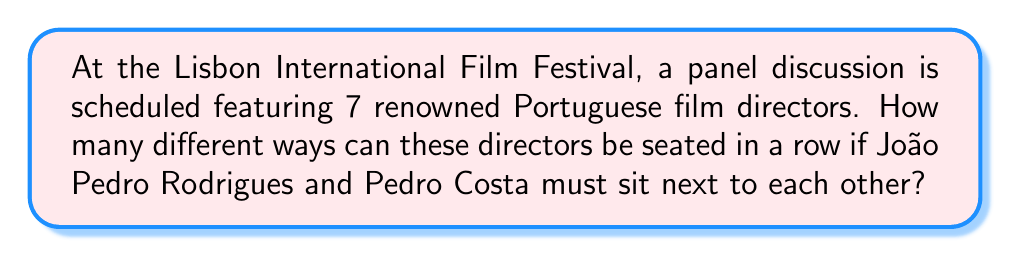Show me your answer to this math problem. Let's approach this step-by-step:

1) First, we need to consider João Pedro Rodrigues and Pedro Costa as a single unit since they must sit next to each other. This reduces our problem to arranging 6 units (the Rodrigues-Costa unit and the other 5 directors).

2) The number of ways to arrange 6 distinct units is a straightforward permutation:

   $P(6) = 6! = 6 \times 5 \times 4 \times 3 \times 2 \times 1 = 720$

3) However, we're not done yet. For each of these 720 arrangements, Rodrigues and Costa can switch their positions with each other. This doubles our possibilities.

4) Therefore, the total number of possible arrangements is:

   $720 \times 2 = 1440$

Thus, there are 1440 different ways to seat the 7 Portuguese film directors with Rodrigues and Costa sitting next to each other.
Answer: $1440$ ways 